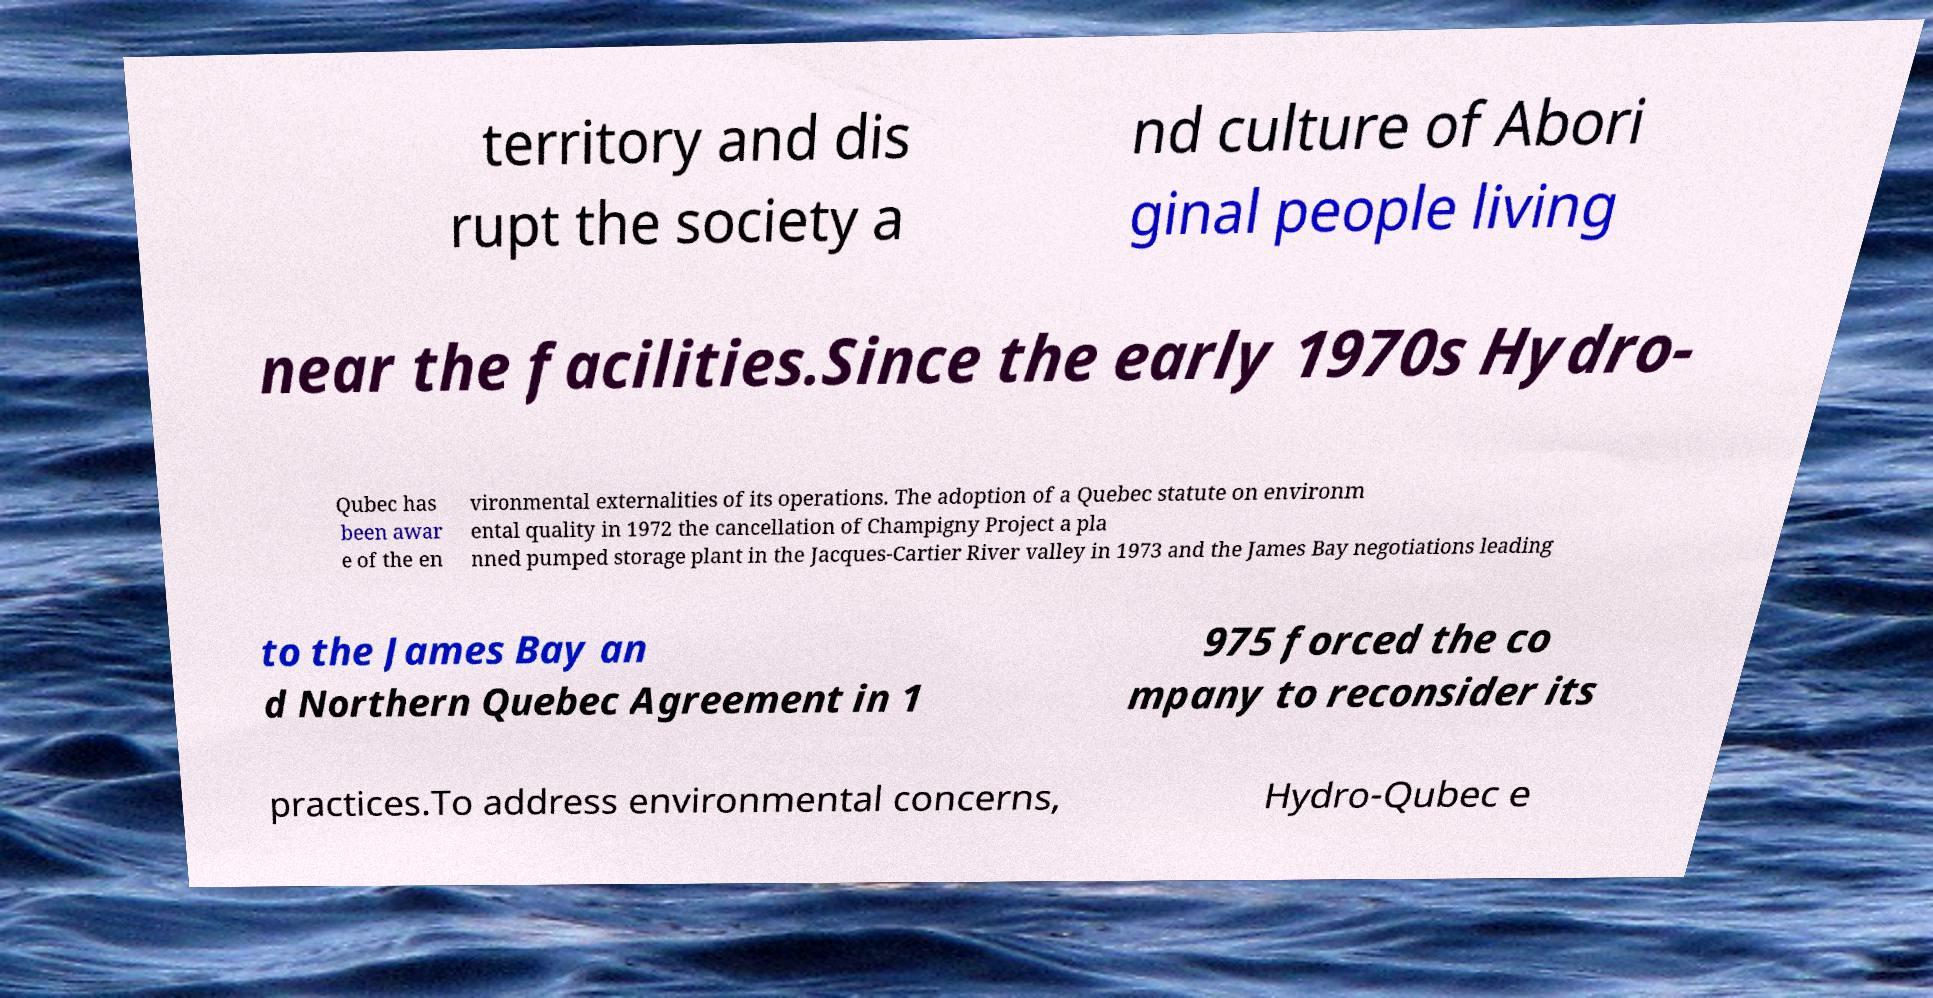What messages or text are displayed in this image? I need them in a readable, typed format. territory and dis rupt the society a nd culture of Abori ginal people living near the facilities.Since the early 1970s Hydro- Qubec has been awar e of the en vironmental externalities of its operations. The adoption of a Quebec statute on environm ental quality in 1972 the cancellation of Champigny Project a pla nned pumped storage plant in the Jacques-Cartier River valley in 1973 and the James Bay negotiations leading to the James Bay an d Northern Quebec Agreement in 1 975 forced the co mpany to reconsider its practices.To address environmental concerns, Hydro-Qubec e 